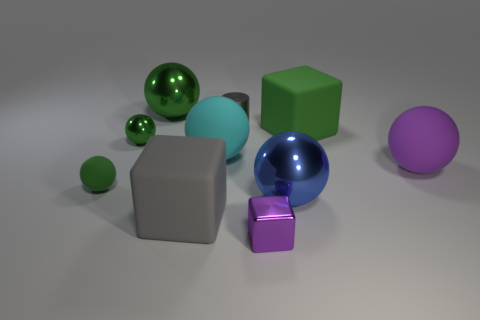How many green spheres must be subtracted to get 1 green spheres? 2 Subtract all red cubes. How many green spheres are left? 3 Subtract all small green metallic balls. How many balls are left? 5 Subtract all purple balls. How many balls are left? 5 Subtract all brown spheres. Subtract all green cylinders. How many spheres are left? 6 Subtract all cylinders. How many objects are left? 9 Add 6 green matte objects. How many green matte objects exist? 8 Subtract 0 red spheres. How many objects are left? 10 Subtract all tiny green rubber balls. Subtract all large rubber cubes. How many objects are left? 7 Add 3 large rubber spheres. How many large rubber spheres are left? 5 